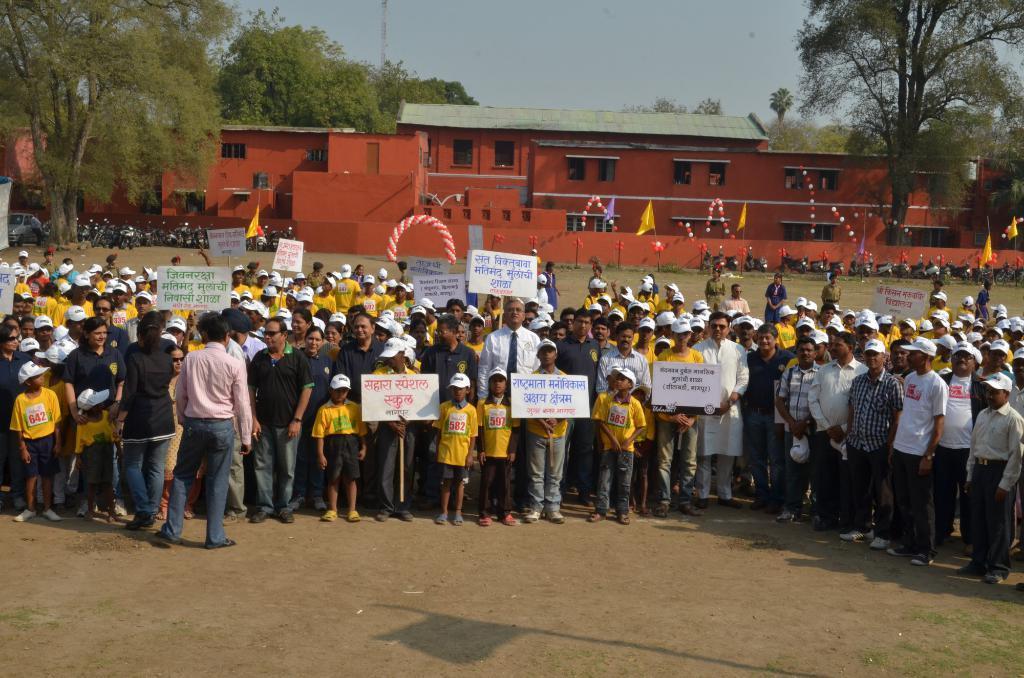In one or two sentences, can you explain what this image depicts? In this image, there are a few people. Among them, some people are holding some boards with text. We can see the ground. We can also see some balloons, flags, poles and decorative objects. There are a few trees, vehicles, buildings. We can see an object on the left. We can also see the sky. We can also see an object at the top. 